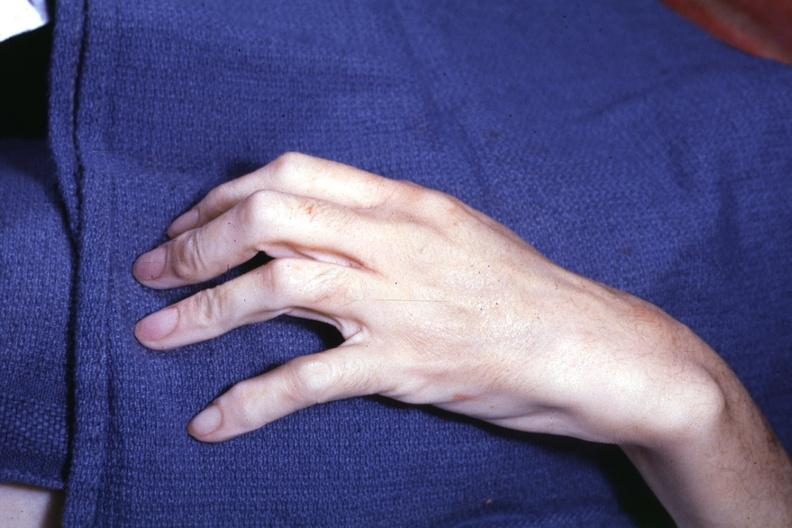what are present?
Answer the question using a single word or phrase. Extremities 